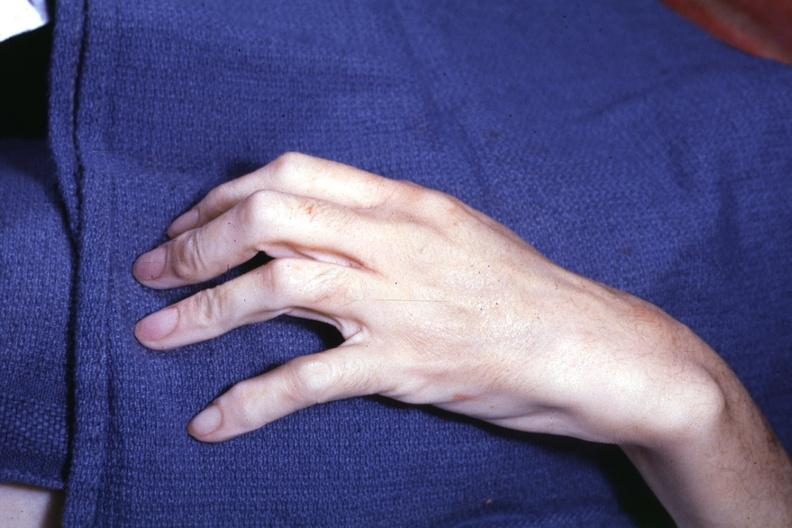what are present?
Answer the question using a single word or phrase. Extremities 